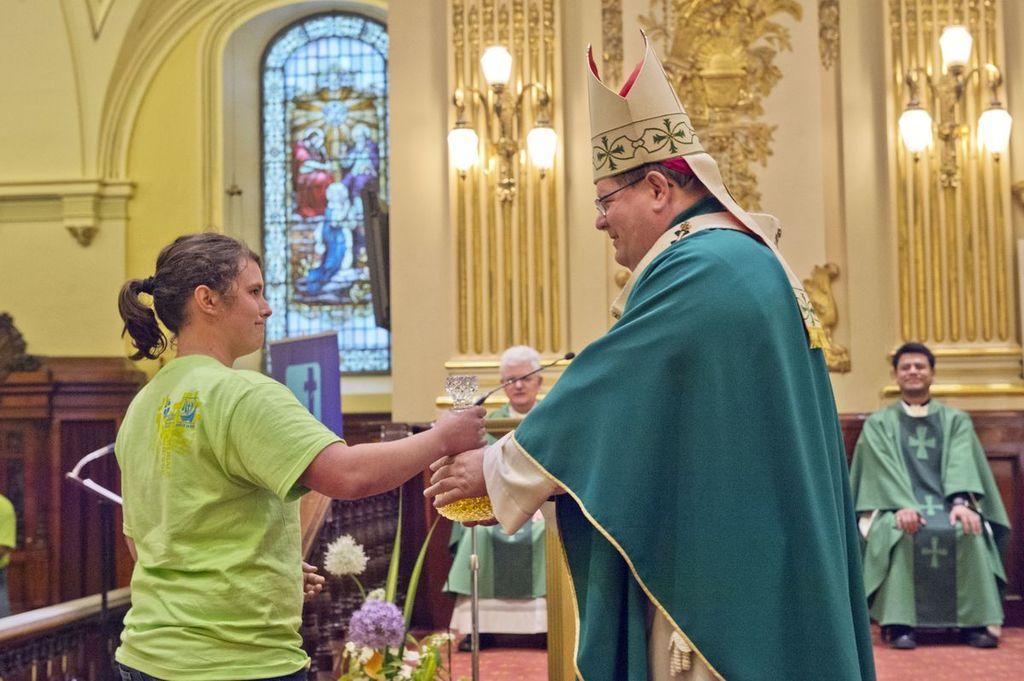How would you summarize this image in a sentence or two? In this image at the center there is a mike. Beside the mike there are two persons standing by holding the mike. Behind them there are two persons sitting on the chair. At the back side there are two chandeliers. At the left side of the image there is a glass window. 